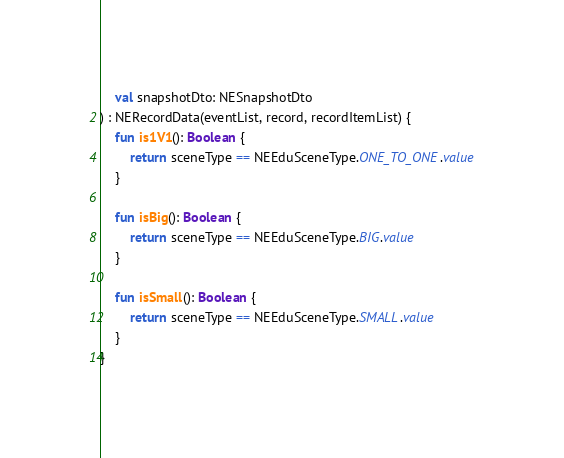<code> <loc_0><loc_0><loc_500><loc_500><_Kotlin_>    val snapshotDto: NESnapshotDto
) : NERecordData(eventList, record, recordItemList) {
    fun is1V1(): Boolean {
        return sceneType == NEEduSceneType.ONE_TO_ONE.value
    }

    fun isBig(): Boolean {
        return sceneType == NEEduSceneType.BIG.value
    }

    fun isSmall(): Boolean {
        return sceneType == NEEduSceneType.SMALL.value
    }
}</code> 